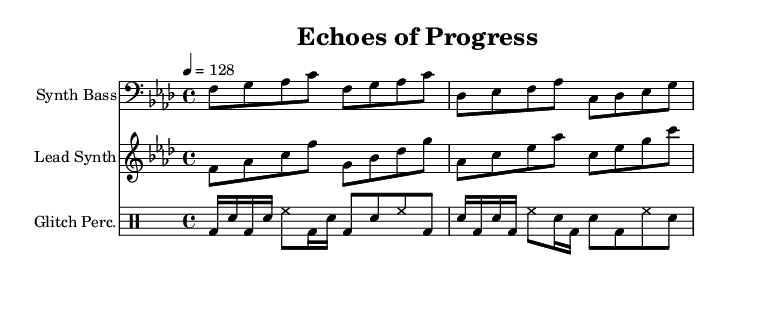What is the key signature of this music? The key signature is indicated at the beginning of the staff. It shows that there are four flats, which corresponds to the key of F minor.
Answer: F minor What is the time signature of this music? The time signature is located after the key signature at the beginning of the piece. It shows 4 beats in each measure, which is represented as 4/4.
Answer: 4/4 What is the tempo marking for this music? The tempo marking is found above the staff and states "4 = 128", indicating that there are 128 beats per minute.
Answer: 128 How many measures are in the synth bass part? By counting the groups of notes divided by vertical lines, there are a total of eight measures in the synth bass part.
Answer: Eight What type of percussion is used in this track? The percussion part includes various symbols represented in the staff that follow a specific rhythm. The notation indicates the use of bass drum (bd), snare (sn), and hi-hat (hh), common in glitch-hop.
Answer: Glitch percussion Which instrument appears in the treble clef? The treble clef shows the notes that are played by a higher-pitched instrument. Here, the lead synth explores melodic patterns in the treble clef.
Answer: Lead synth Are there any rests in the glitch percussion part? A careful look at the percussion staff shows there are moments where no beats are played. These are represented by rests, indicating pauses in the rhythm throughout its structure.
Answer: Yes 